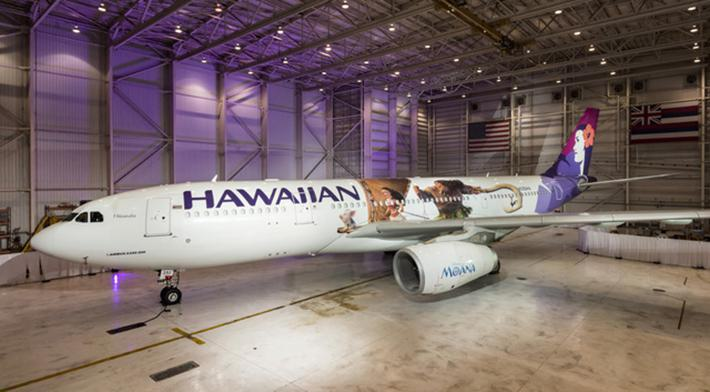What details can you tell me about the airplane shown in the image? The airplane is a commercial jet bearing the livery of Hawaiian Airlines. The design elements include images symbolizing Hawaiian culture and the Aloha spirit, such as the silhouette of a person in traditional Hawaiian attire and tropical imagery. It is likely a model used for medium to long-haul flights, given its size and the dual engines. 